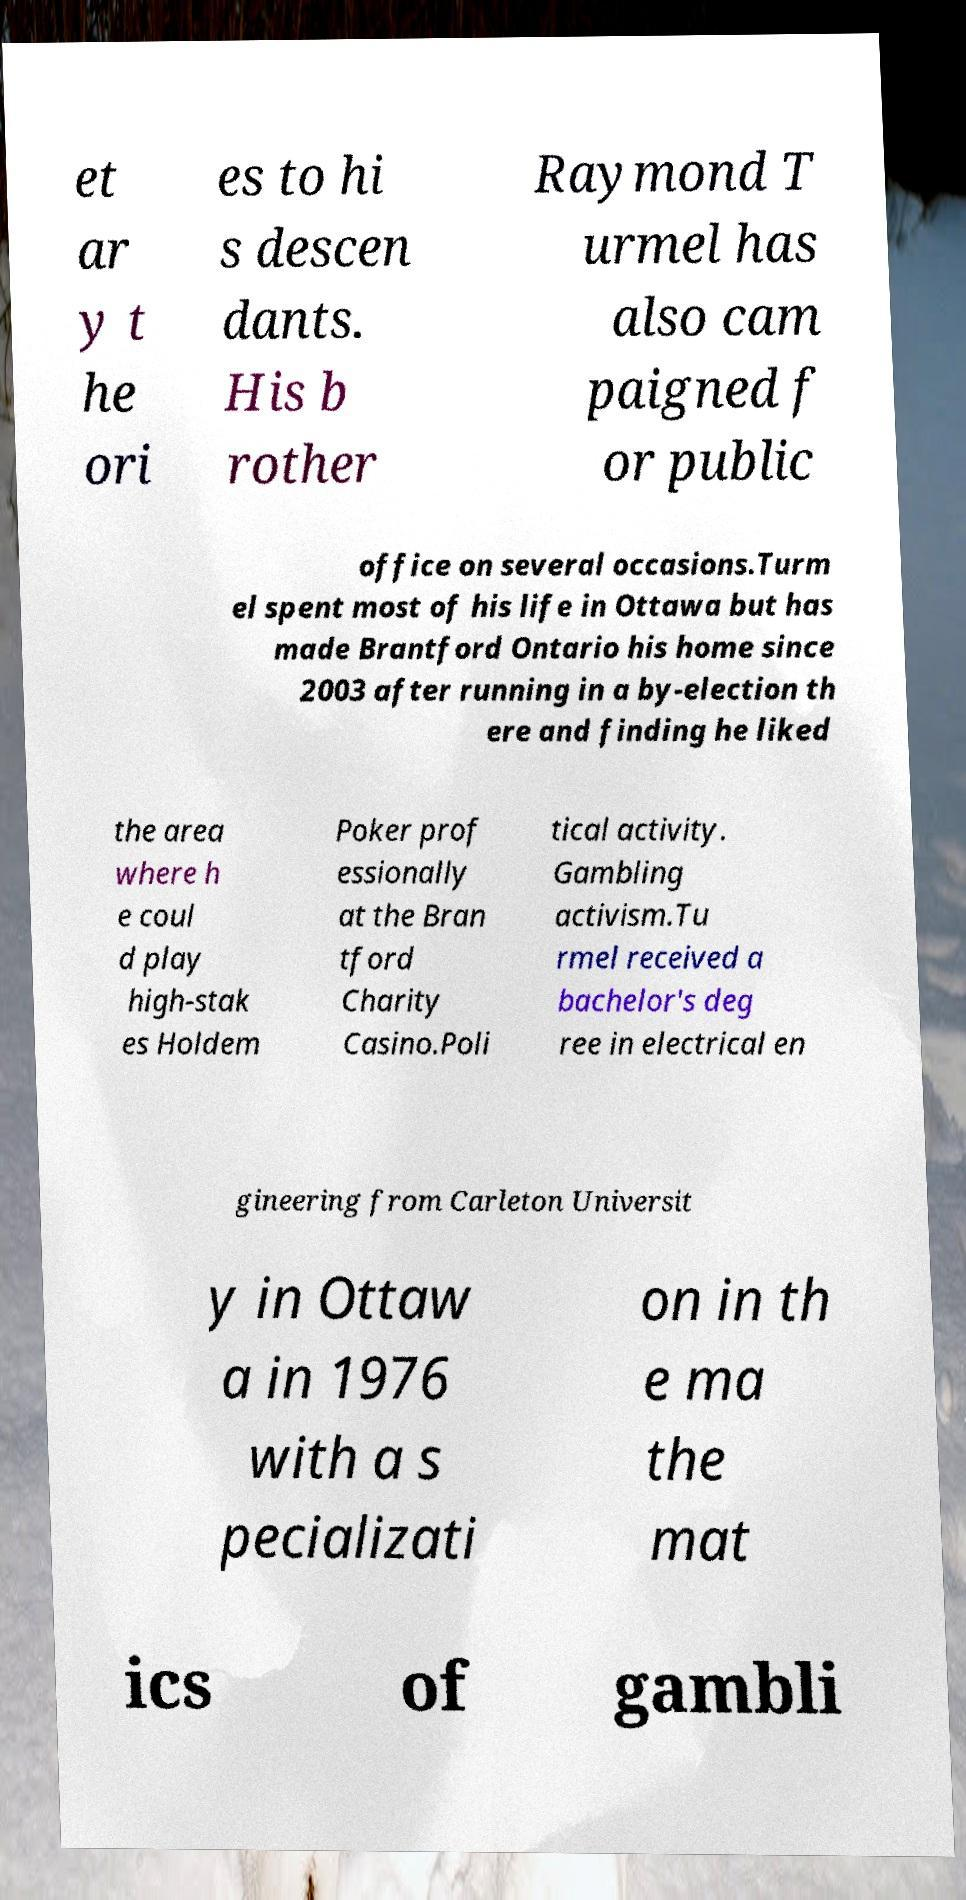Can you accurately transcribe the text from the provided image for me? et ar y t he ori es to hi s descen dants. His b rother Raymond T urmel has also cam paigned f or public office on several occasions.Turm el spent most of his life in Ottawa but has made Brantford Ontario his home since 2003 after running in a by-election th ere and finding he liked the area where h e coul d play high-stak es Holdem Poker prof essionally at the Bran tford Charity Casino.Poli tical activity. Gambling activism.Tu rmel received a bachelor's deg ree in electrical en gineering from Carleton Universit y in Ottaw a in 1976 with a s pecializati on in th e ma the mat ics of gambli 